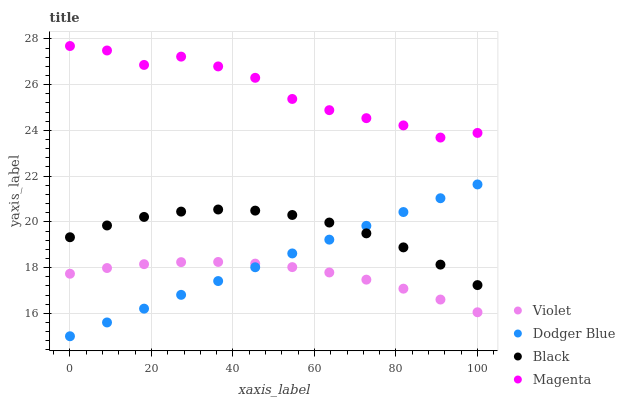Does Violet have the minimum area under the curve?
Answer yes or no. Yes. Does Magenta have the maximum area under the curve?
Answer yes or no. Yes. Does Dodger Blue have the minimum area under the curve?
Answer yes or no. No. Does Dodger Blue have the maximum area under the curve?
Answer yes or no. No. Is Dodger Blue the smoothest?
Answer yes or no. Yes. Is Magenta the roughest?
Answer yes or no. Yes. Is Magenta the smoothest?
Answer yes or no. No. Is Dodger Blue the roughest?
Answer yes or no. No. Does Dodger Blue have the lowest value?
Answer yes or no. Yes. Does Magenta have the lowest value?
Answer yes or no. No. Does Magenta have the highest value?
Answer yes or no. Yes. Does Dodger Blue have the highest value?
Answer yes or no. No. Is Black less than Magenta?
Answer yes or no. Yes. Is Black greater than Violet?
Answer yes or no. Yes. Does Violet intersect Dodger Blue?
Answer yes or no. Yes. Is Violet less than Dodger Blue?
Answer yes or no. No. Is Violet greater than Dodger Blue?
Answer yes or no. No. Does Black intersect Magenta?
Answer yes or no. No. 